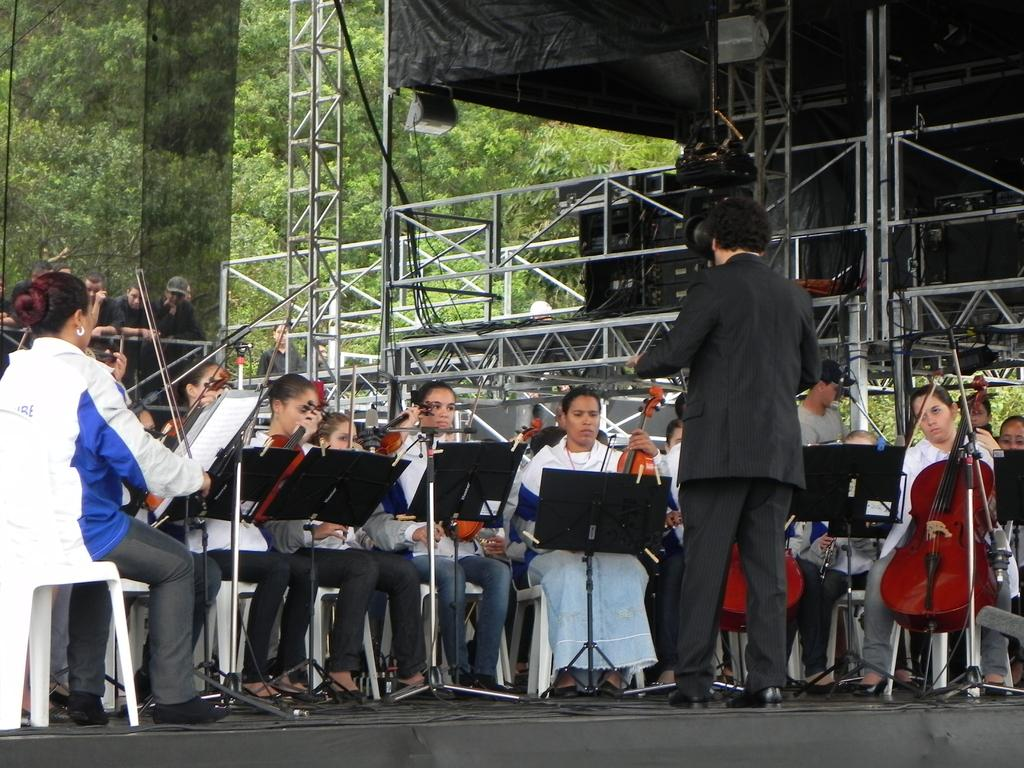What is the main subject of the image? There is a man standing in the image. What are the people in the image doing? The people are playing violins with their hands. Where is the scene taking place? The scene takes place on a stage. Can you describe the background of the image? There are people and trees visible in the background of the image. What type of sweater is the man wearing in the image? The provided facts do not mention any clothing, including a sweater, so we cannot determine what type of sweater the man is wearing in the image. Can you see a mountain in the background of the image? There is no mention of a mountain in the background of the image; it only mentions people and trees. 